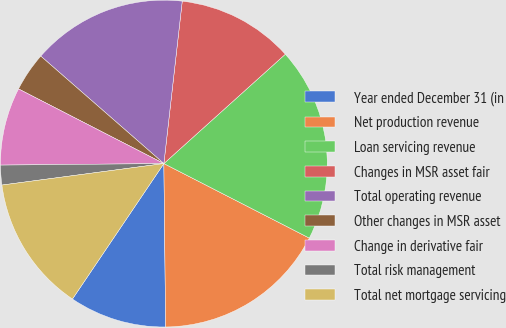Convert chart to OTSL. <chart><loc_0><loc_0><loc_500><loc_500><pie_chart><fcel>Year ended December 31 (in<fcel>Net production revenue<fcel>Loan servicing revenue<fcel>Changes in MSR asset fair<fcel>Total operating revenue<fcel>Other changes in MSR asset<fcel>Change in derivative fair<fcel>Total risk management<fcel>Total net mortgage servicing<nl><fcel>9.62%<fcel>17.29%<fcel>19.2%<fcel>11.54%<fcel>15.37%<fcel>3.87%<fcel>7.7%<fcel>1.95%<fcel>13.45%<nl></chart> 